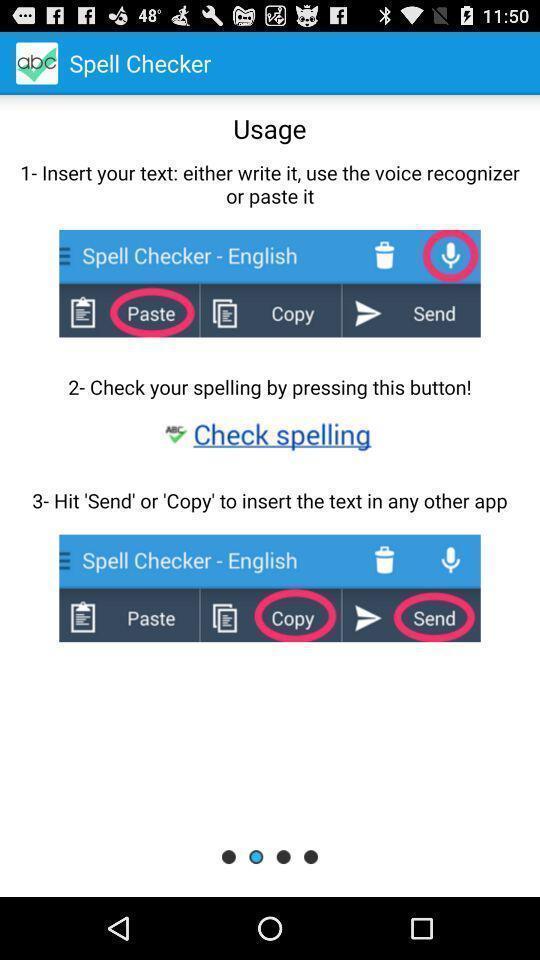Provide a description of this screenshot. Welcome page. 